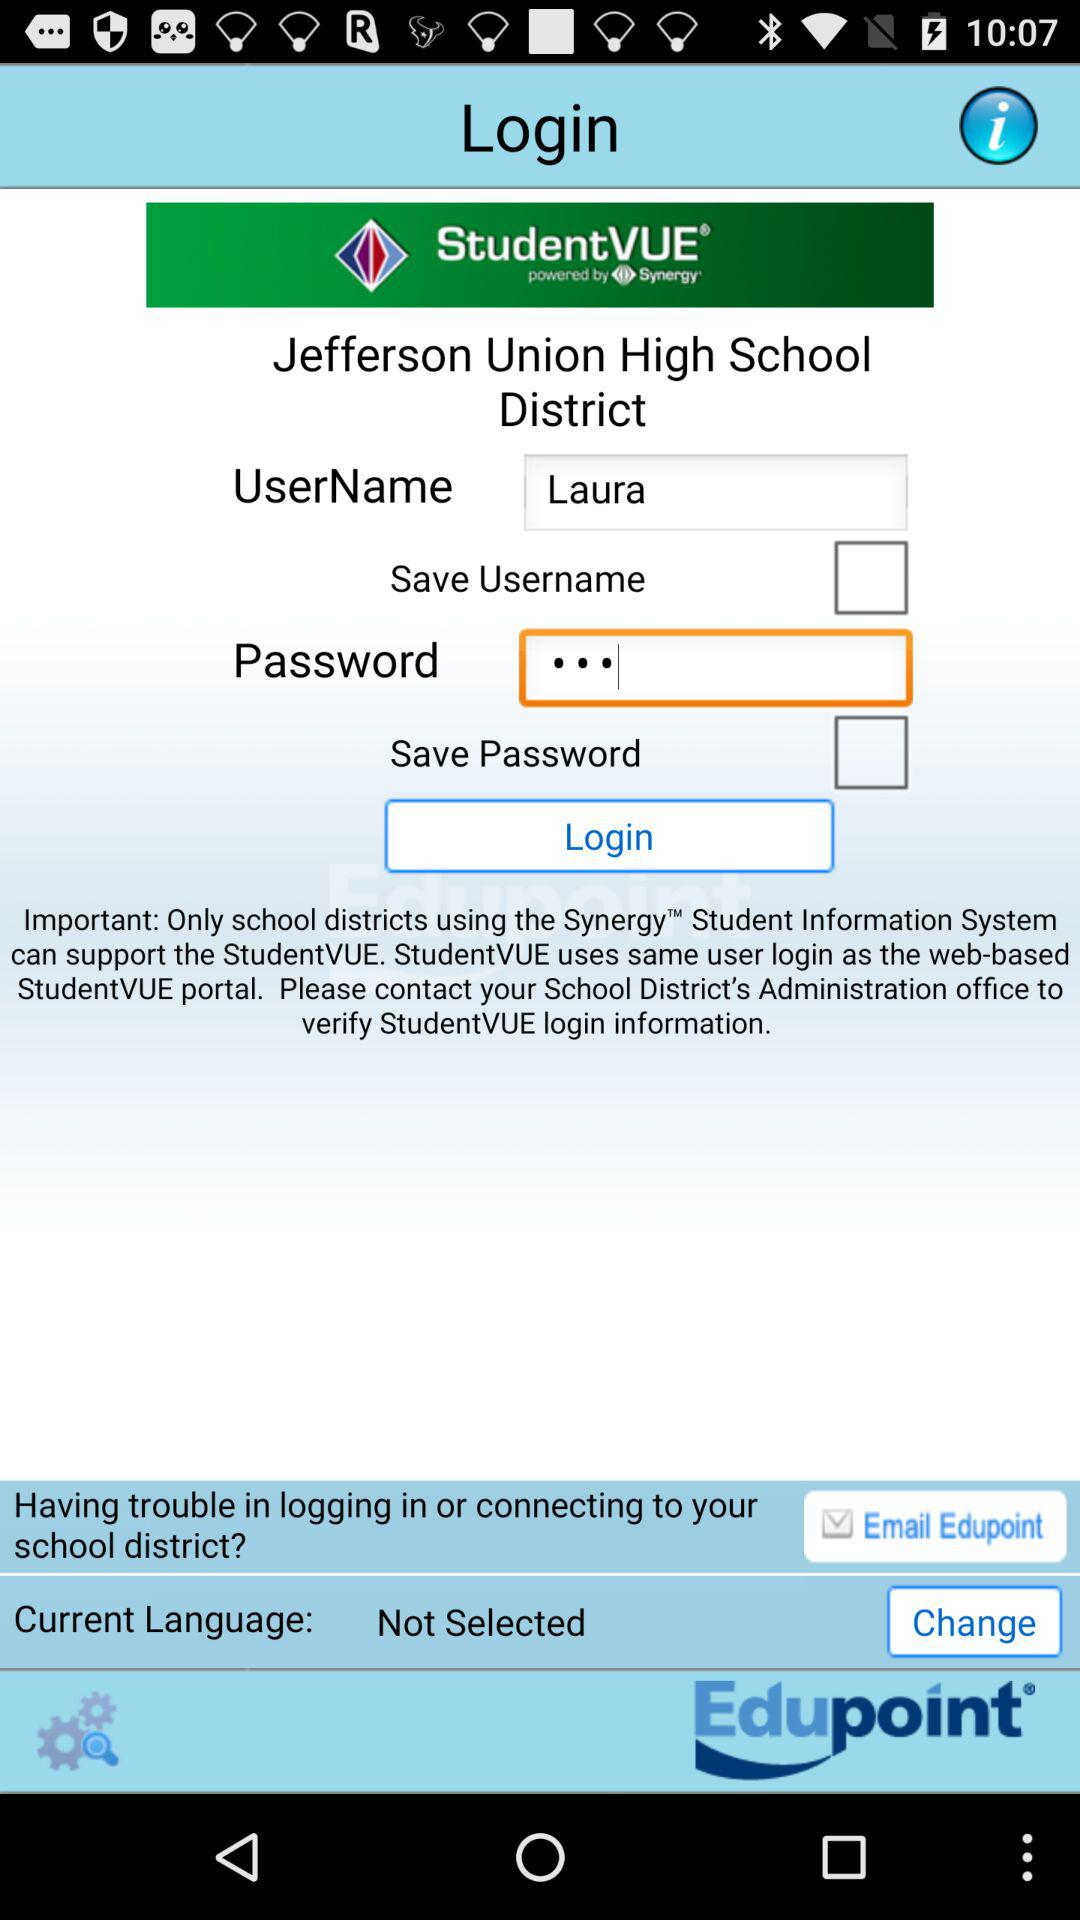What is the user name? The user name is Laura. 